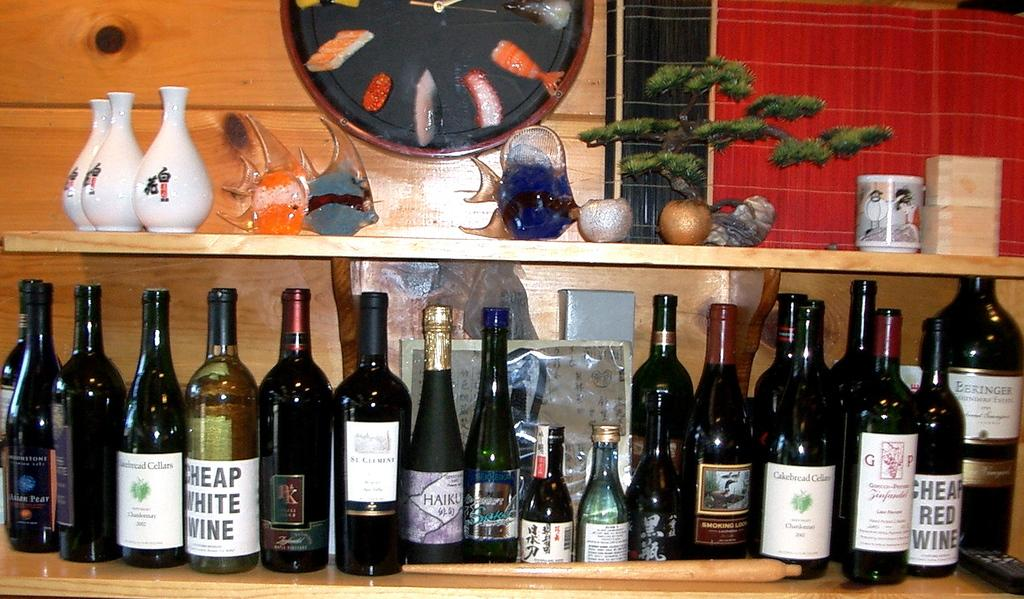<image>
Share a concise interpretation of the image provided. A bottle of cheap white wine is on a shelf with many other wine bottles. 